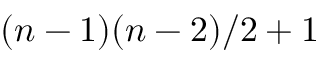<formula> <loc_0><loc_0><loc_500><loc_500>( n - 1 ) ( n - 2 ) / 2 + 1</formula> 